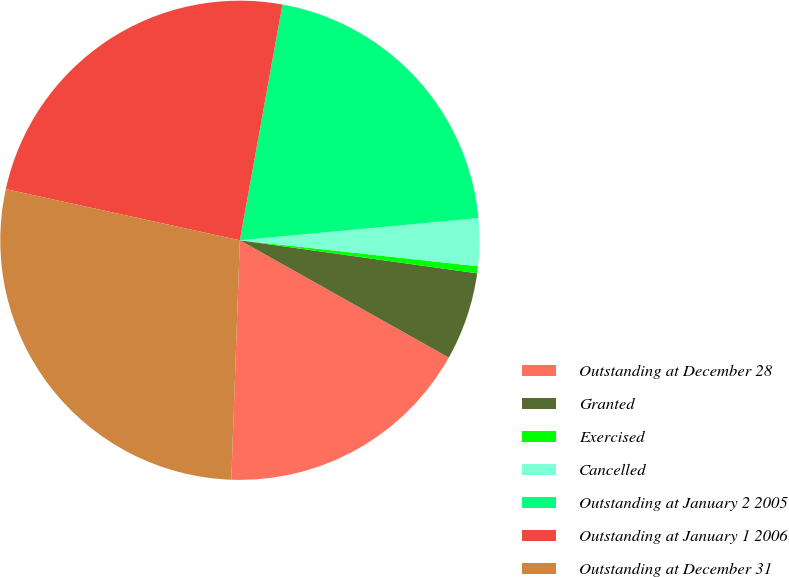Convert chart. <chart><loc_0><loc_0><loc_500><loc_500><pie_chart><fcel>Outstanding at December 28<fcel>Granted<fcel>Exercised<fcel>Cancelled<fcel>Outstanding at January 2 2005<fcel>Outstanding at January 1 2006<fcel>Outstanding at December 31<nl><fcel>17.43%<fcel>5.94%<fcel>0.47%<fcel>3.21%<fcel>20.68%<fcel>24.42%<fcel>27.86%<nl></chart> 